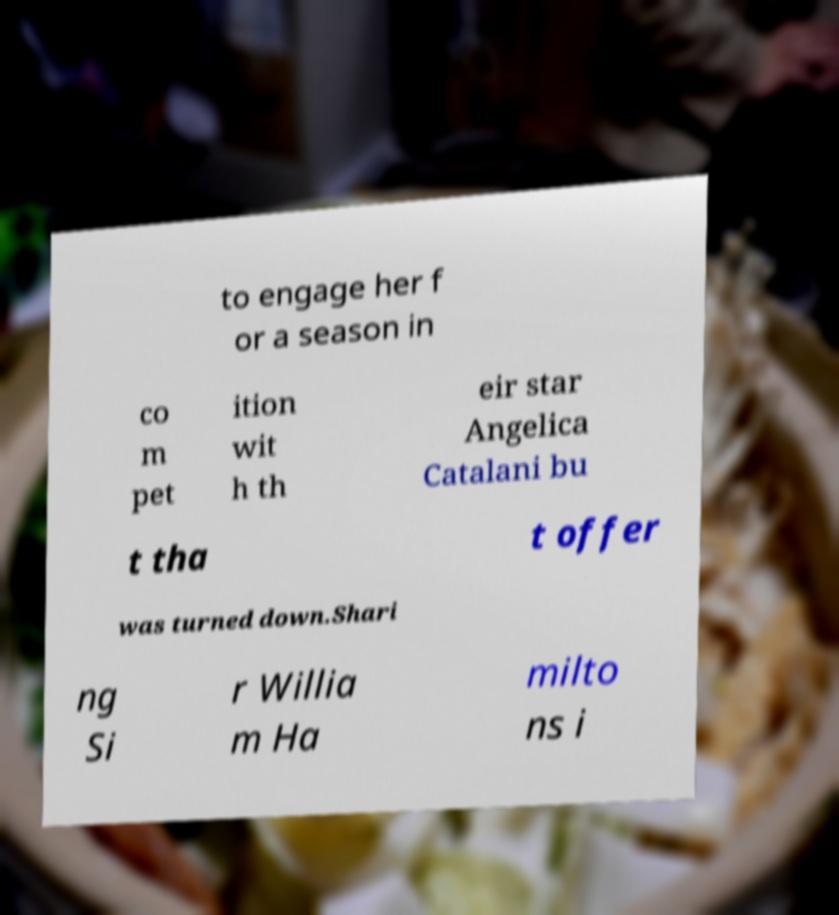Please read and relay the text visible in this image. What does it say? to engage her f or a season in co m pet ition wit h th eir star Angelica Catalani bu t tha t offer was turned down.Shari ng Si r Willia m Ha milto ns i 